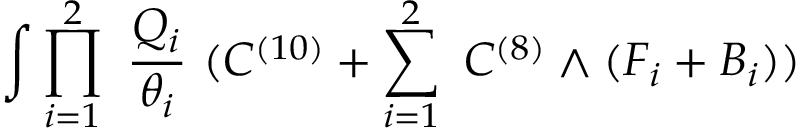Convert formula to latex. <formula><loc_0><loc_0><loc_500><loc_500>\int \prod _ { i = 1 } ^ { 2 } \frac { Q _ { i } } { \theta _ { i } } ( C ^ { ( 1 0 ) } + \sum _ { i = 1 } ^ { 2 } C ^ { ( 8 ) } \wedge ( F _ { i } + B _ { i } ) )</formula> 